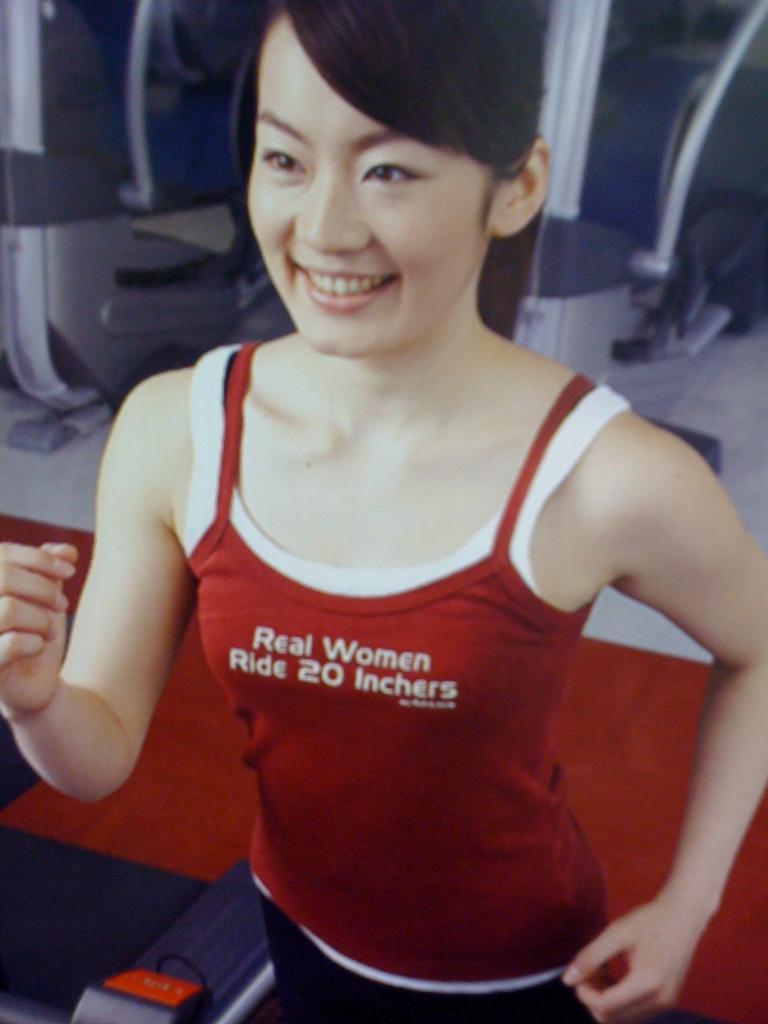Describe this image in one or two sentences. In this image we can see a woman and few objects in the background and a red color carpet on the floor. 